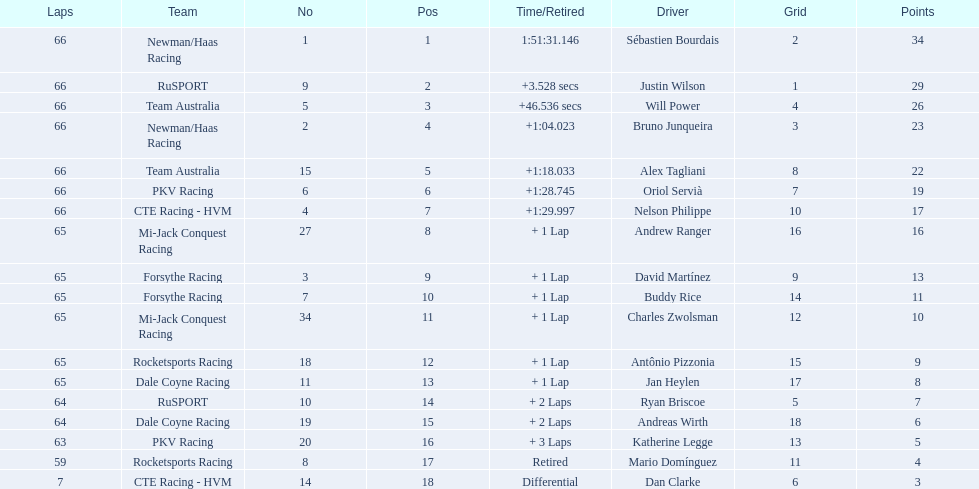How many laps did oriol servia complete at the 2006 gran premio? 66. How many laps did katherine legge complete at the 2006 gran premio? 63. Between servia and legge, who completed more laps? Oriol Servià. 